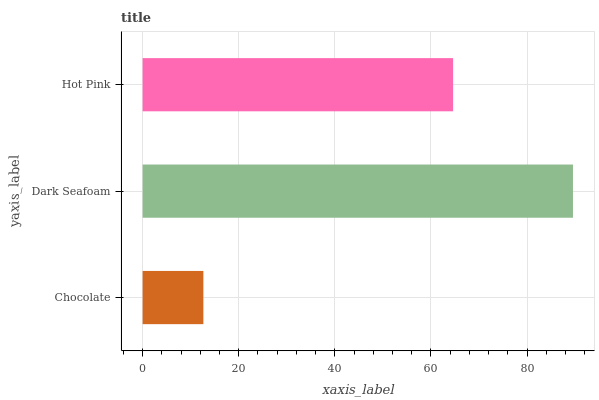Is Chocolate the minimum?
Answer yes or no. Yes. Is Dark Seafoam the maximum?
Answer yes or no. Yes. Is Hot Pink the minimum?
Answer yes or no. No. Is Hot Pink the maximum?
Answer yes or no. No. Is Dark Seafoam greater than Hot Pink?
Answer yes or no. Yes. Is Hot Pink less than Dark Seafoam?
Answer yes or no. Yes. Is Hot Pink greater than Dark Seafoam?
Answer yes or no. No. Is Dark Seafoam less than Hot Pink?
Answer yes or no. No. Is Hot Pink the high median?
Answer yes or no. Yes. Is Hot Pink the low median?
Answer yes or no. Yes. Is Chocolate the high median?
Answer yes or no. No. Is Chocolate the low median?
Answer yes or no. No. 